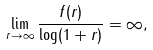Convert formula to latex. <formula><loc_0><loc_0><loc_500><loc_500>\lim _ { r \to \infty } \frac { f ( r ) } { \log ( 1 + r ) } = \infty ,</formula> 